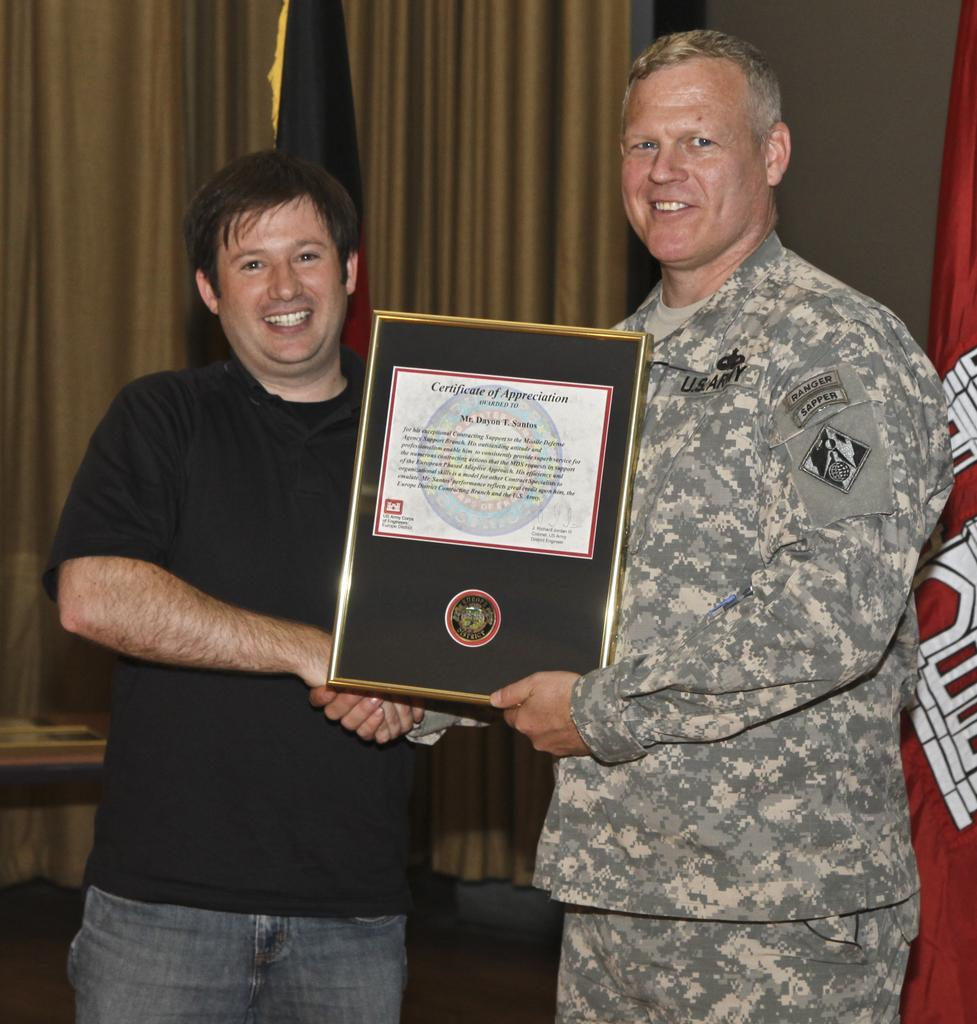How many people are in the image? There are two men in the image. What are the men doing in the image? The men are shaking hands and holding a certificate. What can be seen behind the men in the image? There is a curtain, a flag, and a wall visible in the image. What type of coal is being used to fuel the cattle in the image? There is no coal or cattle present in the image; it features two men shaking hands and holding a certificate. 